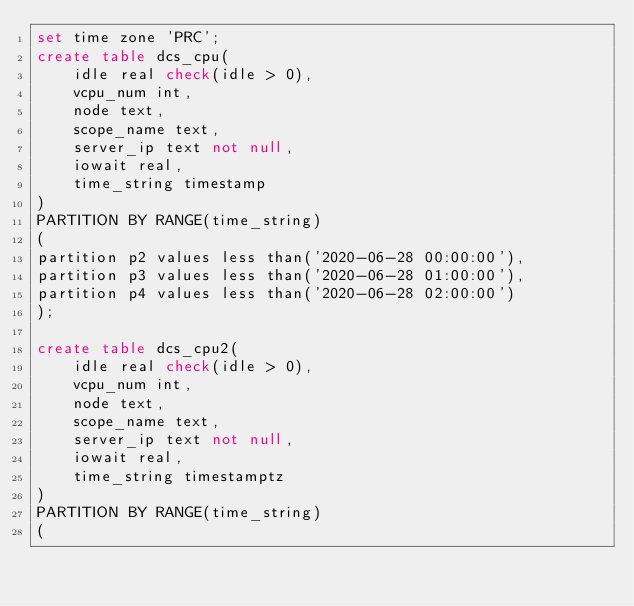<code> <loc_0><loc_0><loc_500><loc_500><_SQL_>set time zone 'PRC';
create table dcs_cpu(
	idle real check(idle > 0),
	vcpu_num int,
	node text,
	scope_name text,
	server_ip text not null,
	iowait real,
	time_string timestamp
)
PARTITION BY RANGE(time_string)
(
partition p2 values less than('2020-06-28 00:00:00'),
partition p3 values less than('2020-06-28 01:00:00'),
partition p4 values less than('2020-06-28 02:00:00')
);

create table dcs_cpu2(
	idle real check(idle > 0),
	vcpu_num int,
	node text,
	scope_name text,
	server_ip text not null,
	iowait real,
	time_string timestamptz
)
PARTITION BY RANGE(time_string)
(</code> 